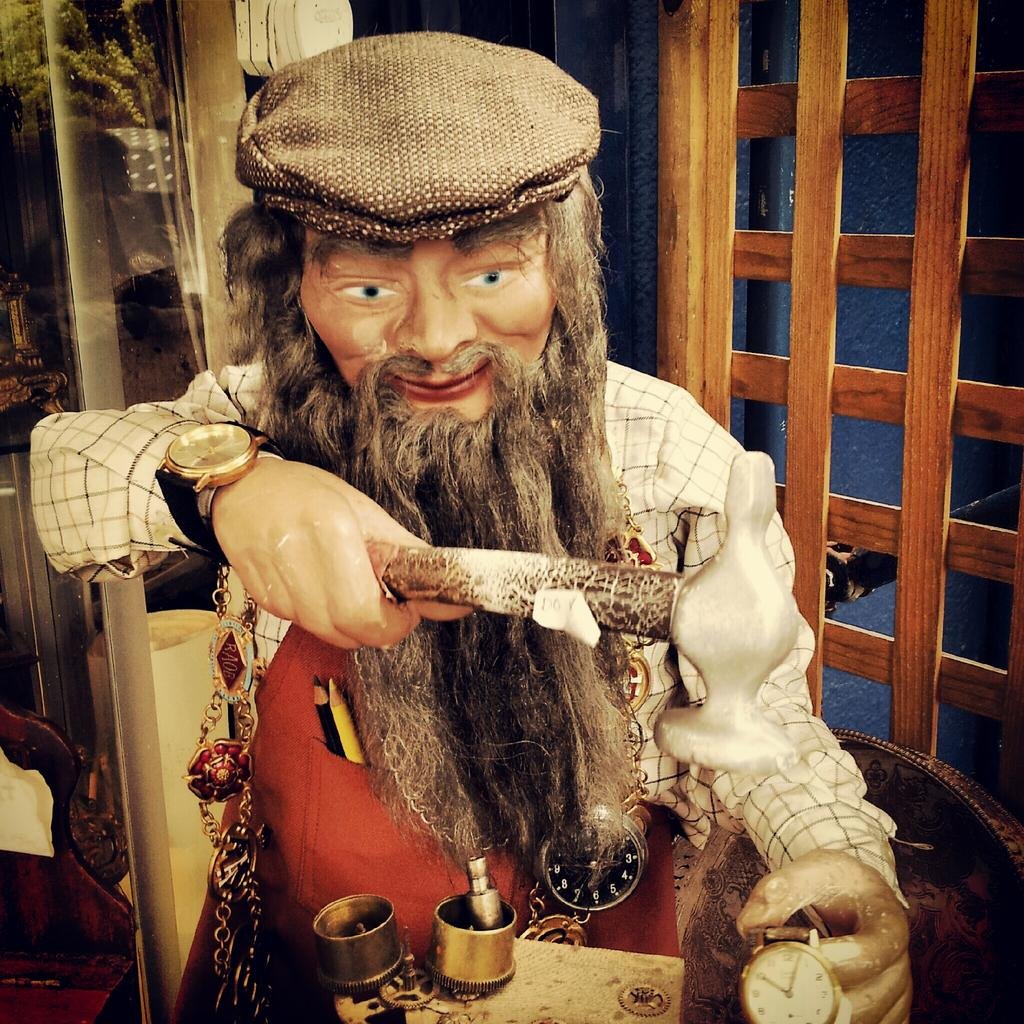What is the main subject in the image? There is a doll in the image. What can be seen in the background of the image? There is a wall and a window in the background of the image. What type of cable is connected to the doll in the image? There is no cable connected to the doll in the image. 